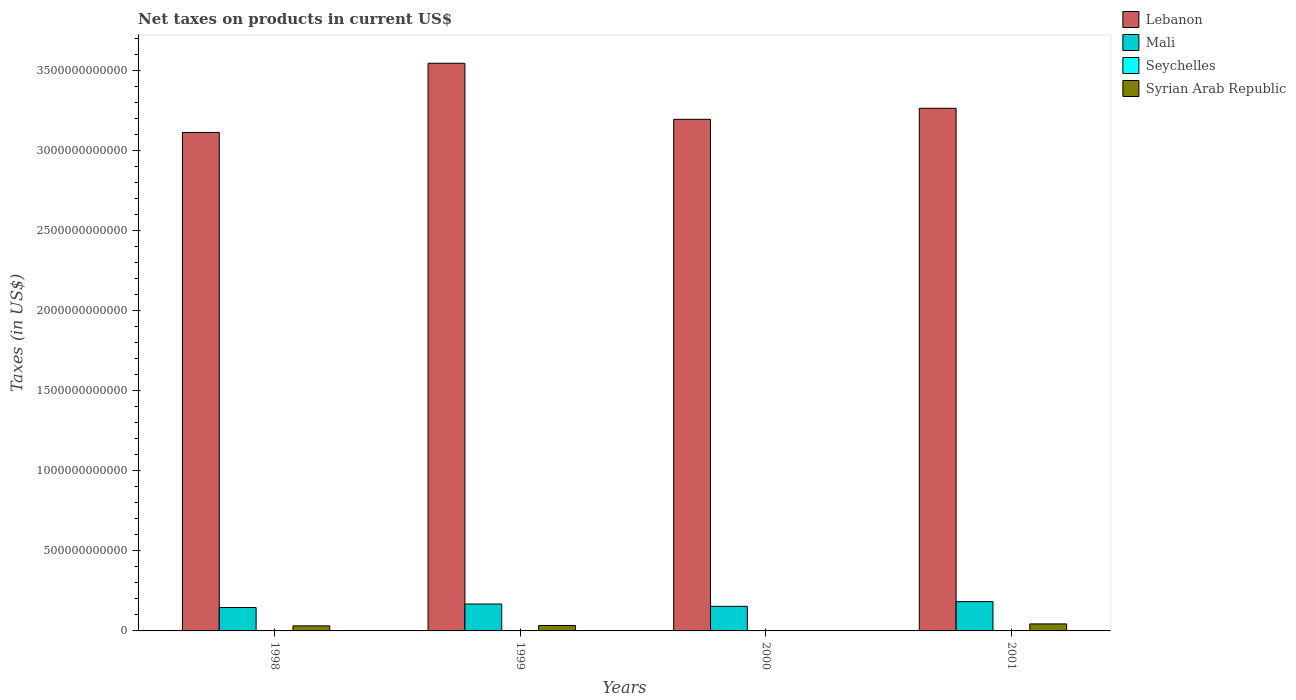How many different coloured bars are there?
Provide a short and direct response. 4. How many groups of bars are there?
Offer a terse response. 4. Are the number of bars per tick equal to the number of legend labels?
Offer a terse response. No. Are the number of bars on each tick of the X-axis equal?
Make the answer very short. No. How many bars are there on the 4th tick from the left?
Ensure brevity in your answer.  4. What is the net taxes on products in Seychelles in 2001?
Keep it short and to the point. 6.34e+08. Across all years, what is the maximum net taxes on products in Seychelles?
Ensure brevity in your answer.  6.34e+08. Across all years, what is the minimum net taxes on products in Lebanon?
Your response must be concise. 3.11e+12. What is the total net taxes on products in Syrian Arab Republic in the graph?
Offer a very short reply. 1.09e+11. What is the difference between the net taxes on products in Syrian Arab Republic in 1998 and that in 2001?
Make the answer very short. -1.22e+1. What is the difference between the net taxes on products in Mali in 2000 and the net taxes on products in Seychelles in 1998?
Provide a succinct answer. 1.53e+11. What is the average net taxes on products in Lebanon per year?
Your answer should be very brief. 3.28e+12. In the year 1998, what is the difference between the net taxes on products in Syrian Arab Republic and net taxes on products in Lebanon?
Your answer should be compact. -3.08e+12. In how many years, is the net taxes on products in Seychelles greater than 1600000000000 US$?
Provide a succinct answer. 0. What is the ratio of the net taxes on products in Syrian Arab Republic in 1999 to that in 2001?
Provide a succinct answer. 0.78. Is the difference between the net taxes on products in Syrian Arab Republic in 1999 and 2001 greater than the difference between the net taxes on products in Lebanon in 1999 and 2001?
Offer a very short reply. No. What is the difference between the highest and the second highest net taxes on products in Mali?
Provide a succinct answer. 1.50e+1. What is the difference between the highest and the lowest net taxes on products in Mali?
Provide a succinct answer. 3.70e+1. In how many years, is the net taxes on products in Seychelles greater than the average net taxes on products in Seychelles taken over all years?
Provide a short and direct response. 2. Is it the case that in every year, the sum of the net taxes on products in Seychelles and net taxes on products in Mali is greater than the net taxes on products in Lebanon?
Provide a short and direct response. No. How many bars are there?
Your response must be concise. 15. How many years are there in the graph?
Offer a terse response. 4. What is the difference between two consecutive major ticks on the Y-axis?
Your response must be concise. 5.00e+11. Does the graph contain any zero values?
Keep it short and to the point. Yes. Does the graph contain grids?
Your answer should be compact. No. What is the title of the graph?
Offer a very short reply. Net taxes on products in current US$. What is the label or title of the X-axis?
Provide a succinct answer. Years. What is the label or title of the Y-axis?
Keep it short and to the point. Taxes (in US$). What is the Taxes (in US$) in Lebanon in 1998?
Give a very brief answer. 3.11e+12. What is the Taxes (in US$) of Mali in 1998?
Your answer should be very brief. 1.46e+11. What is the Taxes (in US$) of Seychelles in 1998?
Ensure brevity in your answer.  3.49e+08. What is the Taxes (in US$) in Syrian Arab Republic in 1998?
Give a very brief answer. 3.15e+1. What is the Taxes (in US$) in Lebanon in 1999?
Your response must be concise. 3.54e+12. What is the Taxes (in US$) in Mali in 1999?
Provide a short and direct response. 1.68e+11. What is the Taxes (in US$) of Seychelles in 1999?
Keep it short and to the point. 3.19e+08. What is the Taxes (in US$) in Syrian Arab Republic in 1999?
Provide a succinct answer. 3.40e+1. What is the Taxes (in US$) of Lebanon in 2000?
Make the answer very short. 3.19e+12. What is the Taxes (in US$) of Mali in 2000?
Provide a succinct answer. 1.53e+11. What is the Taxes (in US$) of Seychelles in 2000?
Your answer should be compact. 6.20e+08. What is the Taxes (in US$) of Lebanon in 2001?
Ensure brevity in your answer.  3.26e+12. What is the Taxes (in US$) of Mali in 2001?
Ensure brevity in your answer.  1.83e+11. What is the Taxes (in US$) of Seychelles in 2001?
Keep it short and to the point. 6.34e+08. What is the Taxes (in US$) of Syrian Arab Republic in 2001?
Keep it short and to the point. 4.37e+1. Across all years, what is the maximum Taxes (in US$) of Lebanon?
Your answer should be compact. 3.54e+12. Across all years, what is the maximum Taxes (in US$) in Mali?
Give a very brief answer. 1.83e+11. Across all years, what is the maximum Taxes (in US$) of Seychelles?
Your answer should be very brief. 6.34e+08. Across all years, what is the maximum Taxes (in US$) of Syrian Arab Republic?
Offer a very short reply. 4.37e+1. Across all years, what is the minimum Taxes (in US$) of Lebanon?
Offer a very short reply. 3.11e+12. Across all years, what is the minimum Taxes (in US$) of Mali?
Offer a terse response. 1.46e+11. Across all years, what is the minimum Taxes (in US$) of Seychelles?
Make the answer very short. 3.19e+08. Across all years, what is the minimum Taxes (in US$) in Syrian Arab Republic?
Your answer should be very brief. 0. What is the total Taxes (in US$) in Lebanon in the graph?
Offer a terse response. 1.31e+13. What is the total Taxes (in US$) in Mali in the graph?
Offer a terse response. 6.50e+11. What is the total Taxes (in US$) in Seychelles in the graph?
Offer a very short reply. 1.92e+09. What is the total Taxes (in US$) of Syrian Arab Republic in the graph?
Make the answer very short. 1.09e+11. What is the difference between the Taxes (in US$) in Lebanon in 1998 and that in 1999?
Your answer should be very brief. -4.32e+11. What is the difference between the Taxes (in US$) in Mali in 1998 and that in 1999?
Offer a very short reply. -2.19e+1. What is the difference between the Taxes (in US$) of Seychelles in 1998 and that in 1999?
Keep it short and to the point. 3.01e+07. What is the difference between the Taxes (in US$) of Syrian Arab Republic in 1998 and that in 1999?
Offer a very short reply. -2.56e+09. What is the difference between the Taxes (in US$) of Lebanon in 1998 and that in 2000?
Your answer should be compact. -8.20e+1. What is the difference between the Taxes (in US$) in Mali in 1998 and that in 2000?
Your response must be concise. -7.48e+09. What is the difference between the Taxes (in US$) of Seychelles in 1998 and that in 2000?
Your response must be concise. -2.72e+08. What is the difference between the Taxes (in US$) in Lebanon in 1998 and that in 2001?
Your answer should be compact. -1.51e+11. What is the difference between the Taxes (in US$) of Mali in 1998 and that in 2001?
Keep it short and to the point. -3.70e+1. What is the difference between the Taxes (in US$) in Seychelles in 1998 and that in 2001?
Make the answer very short. -2.86e+08. What is the difference between the Taxes (in US$) in Syrian Arab Republic in 1998 and that in 2001?
Your answer should be compact. -1.22e+1. What is the difference between the Taxes (in US$) of Lebanon in 1999 and that in 2000?
Ensure brevity in your answer.  3.50e+11. What is the difference between the Taxes (in US$) in Mali in 1999 and that in 2000?
Provide a succinct answer. 1.45e+1. What is the difference between the Taxes (in US$) of Seychelles in 1999 and that in 2000?
Provide a short and direct response. -3.02e+08. What is the difference between the Taxes (in US$) of Lebanon in 1999 and that in 2001?
Ensure brevity in your answer.  2.81e+11. What is the difference between the Taxes (in US$) in Mali in 1999 and that in 2001?
Keep it short and to the point. -1.50e+1. What is the difference between the Taxes (in US$) of Seychelles in 1999 and that in 2001?
Your response must be concise. -3.16e+08. What is the difference between the Taxes (in US$) of Syrian Arab Republic in 1999 and that in 2001?
Your answer should be very brief. -9.69e+09. What is the difference between the Taxes (in US$) in Lebanon in 2000 and that in 2001?
Your response must be concise. -6.90e+1. What is the difference between the Taxes (in US$) of Mali in 2000 and that in 2001?
Your response must be concise. -2.95e+1. What is the difference between the Taxes (in US$) in Seychelles in 2000 and that in 2001?
Provide a short and direct response. -1.41e+07. What is the difference between the Taxes (in US$) in Lebanon in 1998 and the Taxes (in US$) in Mali in 1999?
Give a very brief answer. 2.94e+12. What is the difference between the Taxes (in US$) in Lebanon in 1998 and the Taxes (in US$) in Seychelles in 1999?
Offer a terse response. 3.11e+12. What is the difference between the Taxes (in US$) of Lebanon in 1998 and the Taxes (in US$) of Syrian Arab Republic in 1999?
Your answer should be compact. 3.08e+12. What is the difference between the Taxes (in US$) of Mali in 1998 and the Taxes (in US$) of Seychelles in 1999?
Keep it short and to the point. 1.46e+11. What is the difference between the Taxes (in US$) in Mali in 1998 and the Taxes (in US$) in Syrian Arab Republic in 1999?
Your answer should be compact. 1.12e+11. What is the difference between the Taxes (in US$) of Seychelles in 1998 and the Taxes (in US$) of Syrian Arab Republic in 1999?
Provide a short and direct response. -3.37e+1. What is the difference between the Taxes (in US$) in Lebanon in 1998 and the Taxes (in US$) in Mali in 2000?
Ensure brevity in your answer.  2.96e+12. What is the difference between the Taxes (in US$) of Lebanon in 1998 and the Taxes (in US$) of Seychelles in 2000?
Offer a very short reply. 3.11e+12. What is the difference between the Taxes (in US$) in Mali in 1998 and the Taxes (in US$) in Seychelles in 2000?
Make the answer very short. 1.45e+11. What is the difference between the Taxes (in US$) of Lebanon in 1998 and the Taxes (in US$) of Mali in 2001?
Your answer should be very brief. 2.93e+12. What is the difference between the Taxes (in US$) in Lebanon in 1998 and the Taxes (in US$) in Seychelles in 2001?
Provide a succinct answer. 3.11e+12. What is the difference between the Taxes (in US$) in Lebanon in 1998 and the Taxes (in US$) in Syrian Arab Republic in 2001?
Make the answer very short. 3.07e+12. What is the difference between the Taxes (in US$) of Mali in 1998 and the Taxes (in US$) of Seychelles in 2001?
Make the answer very short. 1.45e+11. What is the difference between the Taxes (in US$) in Mali in 1998 and the Taxes (in US$) in Syrian Arab Republic in 2001?
Keep it short and to the point. 1.02e+11. What is the difference between the Taxes (in US$) in Seychelles in 1998 and the Taxes (in US$) in Syrian Arab Republic in 2001?
Your response must be concise. -4.34e+1. What is the difference between the Taxes (in US$) in Lebanon in 1999 and the Taxes (in US$) in Mali in 2000?
Your answer should be compact. 3.39e+12. What is the difference between the Taxes (in US$) of Lebanon in 1999 and the Taxes (in US$) of Seychelles in 2000?
Provide a succinct answer. 3.54e+12. What is the difference between the Taxes (in US$) in Mali in 1999 and the Taxes (in US$) in Seychelles in 2000?
Your answer should be very brief. 1.67e+11. What is the difference between the Taxes (in US$) of Lebanon in 1999 and the Taxes (in US$) of Mali in 2001?
Give a very brief answer. 3.36e+12. What is the difference between the Taxes (in US$) in Lebanon in 1999 and the Taxes (in US$) in Seychelles in 2001?
Keep it short and to the point. 3.54e+12. What is the difference between the Taxes (in US$) of Lebanon in 1999 and the Taxes (in US$) of Syrian Arab Republic in 2001?
Your answer should be compact. 3.50e+12. What is the difference between the Taxes (in US$) in Mali in 1999 and the Taxes (in US$) in Seychelles in 2001?
Offer a terse response. 1.67e+11. What is the difference between the Taxes (in US$) in Mali in 1999 and the Taxes (in US$) in Syrian Arab Republic in 2001?
Your response must be concise. 1.24e+11. What is the difference between the Taxes (in US$) of Seychelles in 1999 and the Taxes (in US$) of Syrian Arab Republic in 2001?
Keep it short and to the point. -4.34e+1. What is the difference between the Taxes (in US$) in Lebanon in 2000 and the Taxes (in US$) in Mali in 2001?
Keep it short and to the point. 3.01e+12. What is the difference between the Taxes (in US$) of Lebanon in 2000 and the Taxes (in US$) of Seychelles in 2001?
Keep it short and to the point. 3.19e+12. What is the difference between the Taxes (in US$) in Lebanon in 2000 and the Taxes (in US$) in Syrian Arab Republic in 2001?
Provide a succinct answer. 3.15e+12. What is the difference between the Taxes (in US$) of Mali in 2000 and the Taxes (in US$) of Seychelles in 2001?
Ensure brevity in your answer.  1.53e+11. What is the difference between the Taxes (in US$) in Mali in 2000 and the Taxes (in US$) in Syrian Arab Republic in 2001?
Keep it short and to the point. 1.10e+11. What is the difference between the Taxes (in US$) of Seychelles in 2000 and the Taxes (in US$) of Syrian Arab Republic in 2001?
Make the answer very short. -4.31e+1. What is the average Taxes (in US$) of Lebanon per year?
Offer a very short reply. 3.28e+12. What is the average Taxes (in US$) in Mali per year?
Your answer should be very brief. 1.63e+11. What is the average Taxes (in US$) of Seychelles per year?
Your answer should be compact. 4.80e+08. What is the average Taxes (in US$) of Syrian Arab Republic per year?
Make the answer very short. 2.73e+1. In the year 1998, what is the difference between the Taxes (in US$) in Lebanon and Taxes (in US$) in Mali?
Offer a very short reply. 2.97e+12. In the year 1998, what is the difference between the Taxes (in US$) of Lebanon and Taxes (in US$) of Seychelles?
Your answer should be compact. 3.11e+12. In the year 1998, what is the difference between the Taxes (in US$) in Lebanon and Taxes (in US$) in Syrian Arab Republic?
Your answer should be very brief. 3.08e+12. In the year 1998, what is the difference between the Taxes (in US$) of Mali and Taxes (in US$) of Seychelles?
Make the answer very short. 1.46e+11. In the year 1998, what is the difference between the Taxes (in US$) of Mali and Taxes (in US$) of Syrian Arab Republic?
Provide a succinct answer. 1.14e+11. In the year 1998, what is the difference between the Taxes (in US$) in Seychelles and Taxes (in US$) in Syrian Arab Republic?
Your answer should be very brief. -3.11e+1. In the year 1999, what is the difference between the Taxes (in US$) in Lebanon and Taxes (in US$) in Mali?
Make the answer very short. 3.38e+12. In the year 1999, what is the difference between the Taxes (in US$) of Lebanon and Taxes (in US$) of Seychelles?
Offer a very short reply. 3.54e+12. In the year 1999, what is the difference between the Taxes (in US$) in Lebanon and Taxes (in US$) in Syrian Arab Republic?
Your response must be concise. 3.51e+12. In the year 1999, what is the difference between the Taxes (in US$) in Mali and Taxes (in US$) in Seychelles?
Ensure brevity in your answer.  1.68e+11. In the year 1999, what is the difference between the Taxes (in US$) of Mali and Taxes (in US$) of Syrian Arab Republic?
Give a very brief answer. 1.34e+11. In the year 1999, what is the difference between the Taxes (in US$) of Seychelles and Taxes (in US$) of Syrian Arab Republic?
Your answer should be very brief. -3.37e+1. In the year 2000, what is the difference between the Taxes (in US$) in Lebanon and Taxes (in US$) in Mali?
Your answer should be compact. 3.04e+12. In the year 2000, what is the difference between the Taxes (in US$) of Lebanon and Taxes (in US$) of Seychelles?
Offer a very short reply. 3.19e+12. In the year 2000, what is the difference between the Taxes (in US$) in Mali and Taxes (in US$) in Seychelles?
Your response must be concise. 1.53e+11. In the year 2001, what is the difference between the Taxes (in US$) of Lebanon and Taxes (in US$) of Mali?
Your response must be concise. 3.08e+12. In the year 2001, what is the difference between the Taxes (in US$) of Lebanon and Taxes (in US$) of Seychelles?
Give a very brief answer. 3.26e+12. In the year 2001, what is the difference between the Taxes (in US$) in Lebanon and Taxes (in US$) in Syrian Arab Republic?
Provide a short and direct response. 3.22e+12. In the year 2001, what is the difference between the Taxes (in US$) of Mali and Taxes (in US$) of Seychelles?
Your response must be concise. 1.82e+11. In the year 2001, what is the difference between the Taxes (in US$) of Mali and Taxes (in US$) of Syrian Arab Republic?
Give a very brief answer. 1.39e+11. In the year 2001, what is the difference between the Taxes (in US$) of Seychelles and Taxes (in US$) of Syrian Arab Republic?
Provide a short and direct response. -4.31e+1. What is the ratio of the Taxes (in US$) in Lebanon in 1998 to that in 1999?
Your answer should be compact. 0.88. What is the ratio of the Taxes (in US$) of Mali in 1998 to that in 1999?
Your answer should be compact. 0.87. What is the ratio of the Taxes (in US$) of Seychelles in 1998 to that in 1999?
Provide a short and direct response. 1.09. What is the ratio of the Taxes (in US$) in Syrian Arab Republic in 1998 to that in 1999?
Your response must be concise. 0.92. What is the ratio of the Taxes (in US$) of Lebanon in 1998 to that in 2000?
Ensure brevity in your answer.  0.97. What is the ratio of the Taxes (in US$) in Mali in 1998 to that in 2000?
Keep it short and to the point. 0.95. What is the ratio of the Taxes (in US$) of Seychelles in 1998 to that in 2000?
Provide a short and direct response. 0.56. What is the ratio of the Taxes (in US$) in Lebanon in 1998 to that in 2001?
Offer a terse response. 0.95. What is the ratio of the Taxes (in US$) in Mali in 1998 to that in 2001?
Provide a succinct answer. 0.8. What is the ratio of the Taxes (in US$) in Seychelles in 1998 to that in 2001?
Provide a short and direct response. 0.55. What is the ratio of the Taxes (in US$) of Syrian Arab Republic in 1998 to that in 2001?
Offer a terse response. 0.72. What is the ratio of the Taxes (in US$) of Lebanon in 1999 to that in 2000?
Offer a terse response. 1.11. What is the ratio of the Taxes (in US$) of Mali in 1999 to that in 2000?
Keep it short and to the point. 1.09. What is the ratio of the Taxes (in US$) of Seychelles in 1999 to that in 2000?
Ensure brevity in your answer.  0.51. What is the ratio of the Taxes (in US$) of Lebanon in 1999 to that in 2001?
Keep it short and to the point. 1.09. What is the ratio of the Taxes (in US$) of Mali in 1999 to that in 2001?
Your answer should be compact. 0.92. What is the ratio of the Taxes (in US$) in Seychelles in 1999 to that in 2001?
Make the answer very short. 0.5. What is the ratio of the Taxes (in US$) in Syrian Arab Republic in 1999 to that in 2001?
Your answer should be very brief. 0.78. What is the ratio of the Taxes (in US$) in Lebanon in 2000 to that in 2001?
Make the answer very short. 0.98. What is the ratio of the Taxes (in US$) of Mali in 2000 to that in 2001?
Your answer should be compact. 0.84. What is the ratio of the Taxes (in US$) in Seychelles in 2000 to that in 2001?
Offer a very short reply. 0.98. What is the difference between the highest and the second highest Taxes (in US$) of Lebanon?
Keep it short and to the point. 2.81e+11. What is the difference between the highest and the second highest Taxes (in US$) in Mali?
Offer a very short reply. 1.50e+1. What is the difference between the highest and the second highest Taxes (in US$) of Seychelles?
Offer a very short reply. 1.41e+07. What is the difference between the highest and the second highest Taxes (in US$) in Syrian Arab Republic?
Make the answer very short. 9.69e+09. What is the difference between the highest and the lowest Taxes (in US$) in Lebanon?
Make the answer very short. 4.32e+11. What is the difference between the highest and the lowest Taxes (in US$) in Mali?
Ensure brevity in your answer.  3.70e+1. What is the difference between the highest and the lowest Taxes (in US$) of Seychelles?
Your answer should be very brief. 3.16e+08. What is the difference between the highest and the lowest Taxes (in US$) of Syrian Arab Republic?
Your answer should be compact. 4.37e+1. 